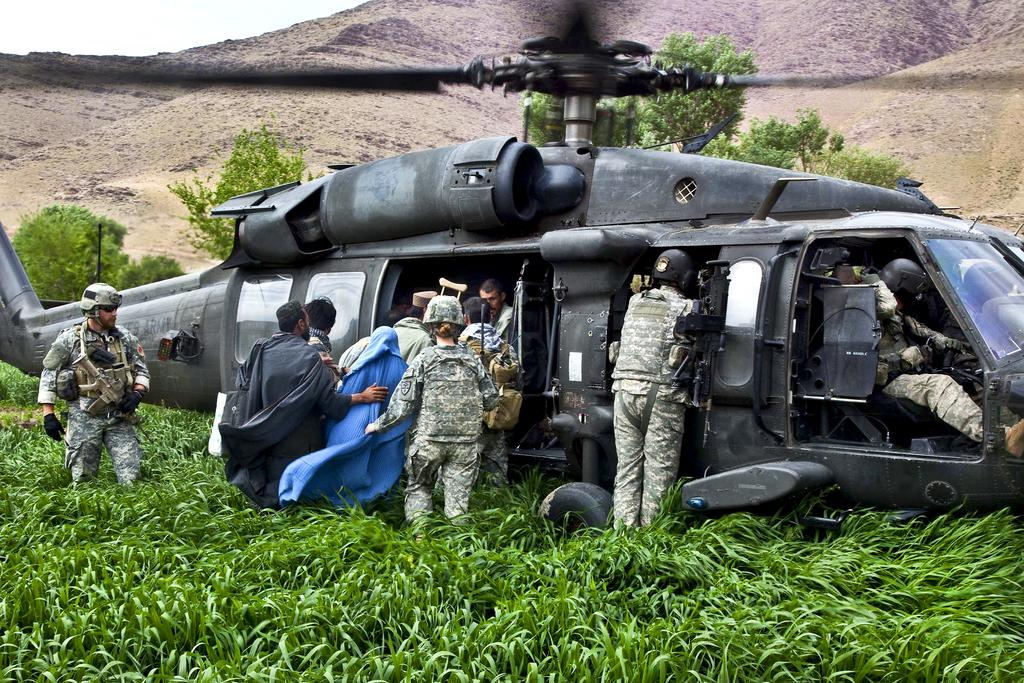What is the main subject in the center of the image? There is a chopper in the center of the image. What are the people in the image doing? People are getting into the chopper. What type of terrain is visible at the bottom of the image? There is grass at the bottom of the image. What can be seen in the distance in the image? There are mountains in the background of the image. What type of stamp can be seen on the chopper in the image? There is no stamp visible on the chopper in the image. What kind of animal is present in the image? There are no animals present in the image. 